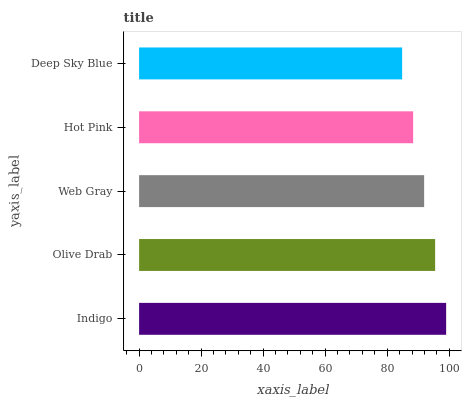Is Deep Sky Blue the minimum?
Answer yes or no. Yes. Is Indigo the maximum?
Answer yes or no. Yes. Is Olive Drab the minimum?
Answer yes or no. No. Is Olive Drab the maximum?
Answer yes or no. No. Is Indigo greater than Olive Drab?
Answer yes or no. Yes. Is Olive Drab less than Indigo?
Answer yes or no. Yes. Is Olive Drab greater than Indigo?
Answer yes or no. No. Is Indigo less than Olive Drab?
Answer yes or no. No. Is Web Gray the high median?
Answer yes or no. Yes. Is Web Gray the low median?
Answer yes or no. Yes. Is Hot Pink the high median?
Answer yes or no. No. Is Hot Pink the low median?
Answer yes or no. No. 